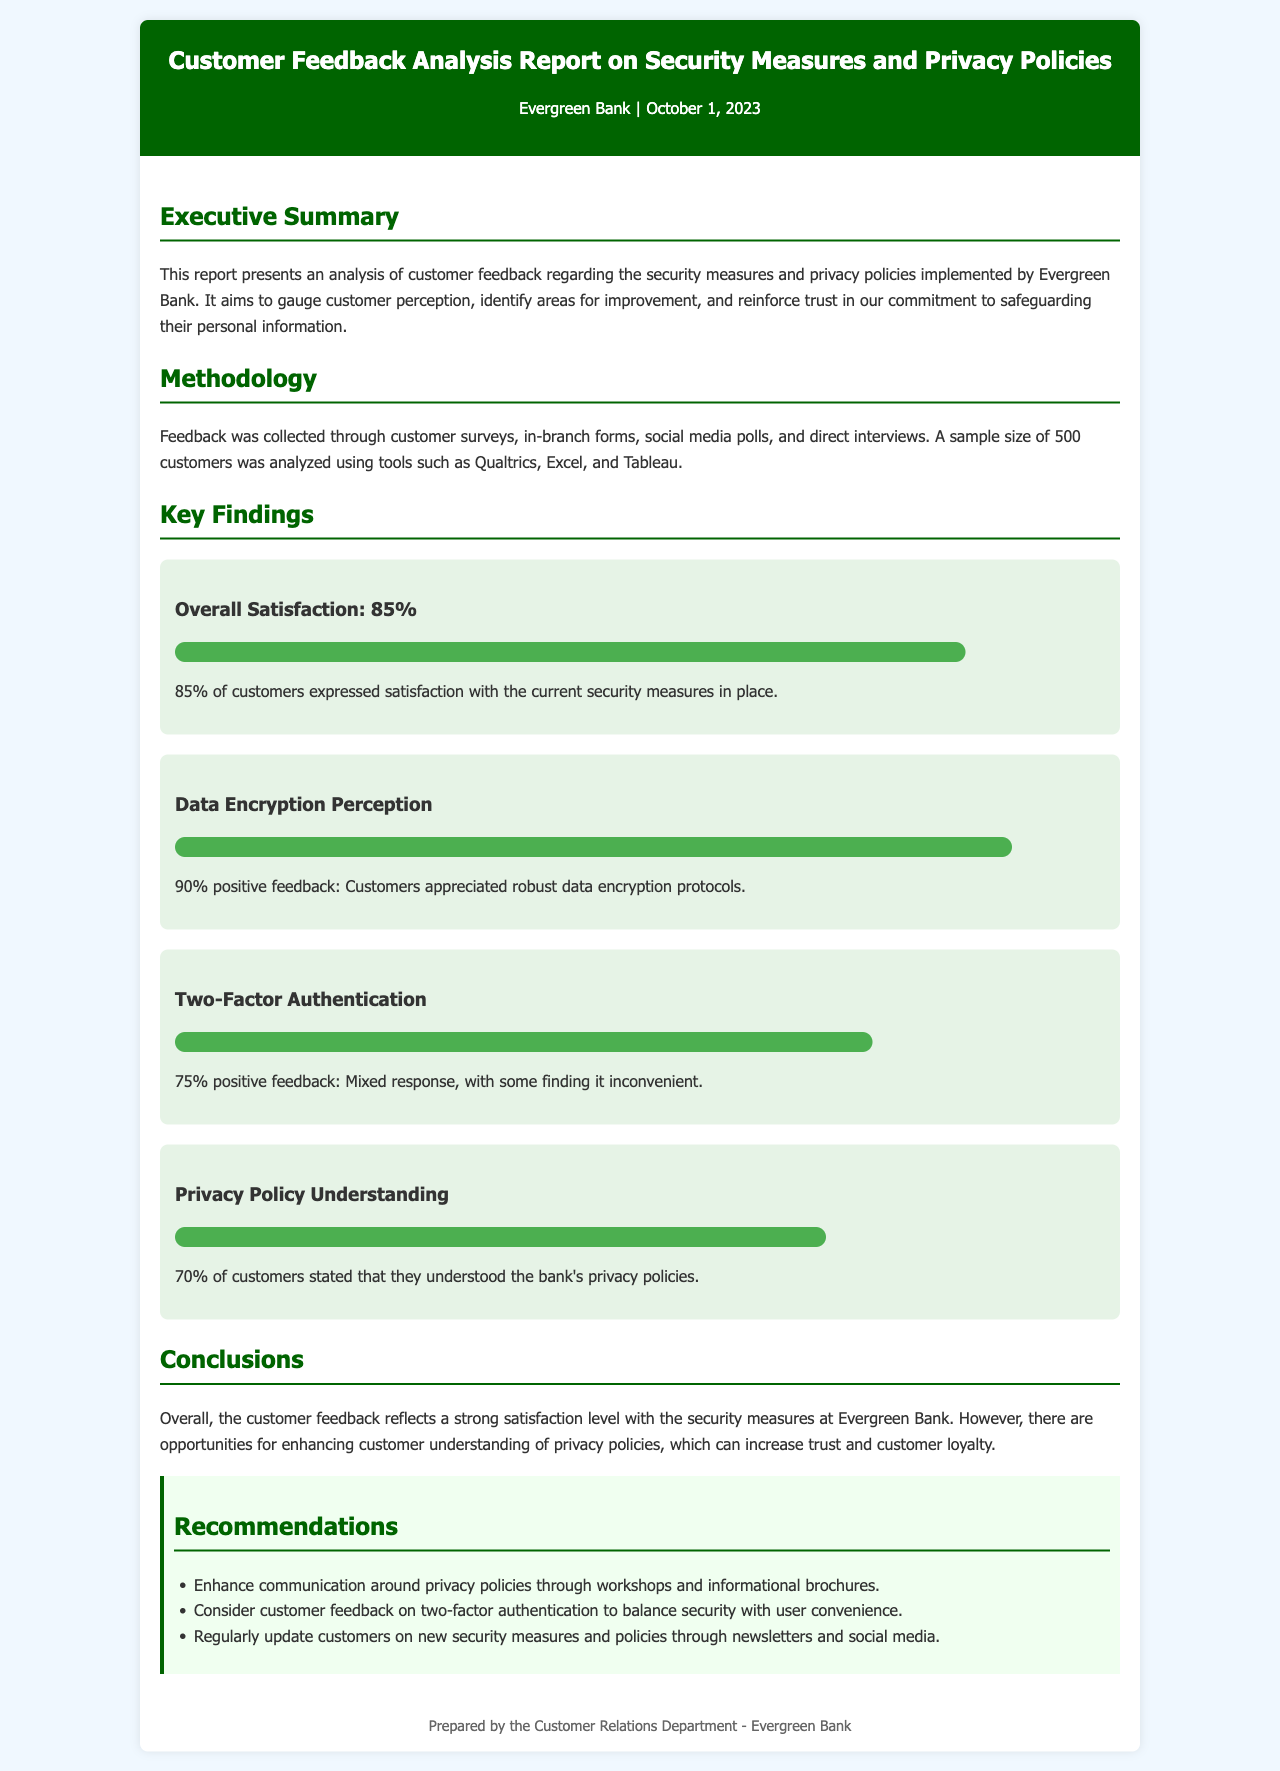What is the overall satisfaction percentage? The overall satisfaction is highlighted in the key findings, showing 85% of customers expressed satisfaction.
Answer: 85% What percentage of customers appreciated data encryption protocols? The report states that 90% of customers provided positive feedback regarding data encryption.
Answer: 90% What is the perception percentage of two-factor authentication? In the report, it indicates that there is a 75% positive feedback regarding the two-factor authentication.
Answer: 75% What percentage of customers understand the bank's privacy policies? The document mentions that 70% of customers stated they understood the bank's privacy policies.
Answer: 70% What is one recommendation made in the report? The recommendations section offers several suggestions, one being to enhance communication around privacy policies.
Answer: Enhance communication around privacy policies What tool was used to analyze the customer feedback? The report states that tools such as Qualtrics, Excel, and Tableau were used for analysis.
Answer: Qualtrics, Excel, and Tableau What main goal does the report aim to achieve? The report's aim is to gauge customer perception and identify areas for improvement regarding security measures.
Answer: Gauge customer perception What is the main finding about customer feedback on security measures? The report concludes that overall customer feedback reflects a strong satisfaction level with the security measures.
Answer: Strong satisfaction level 